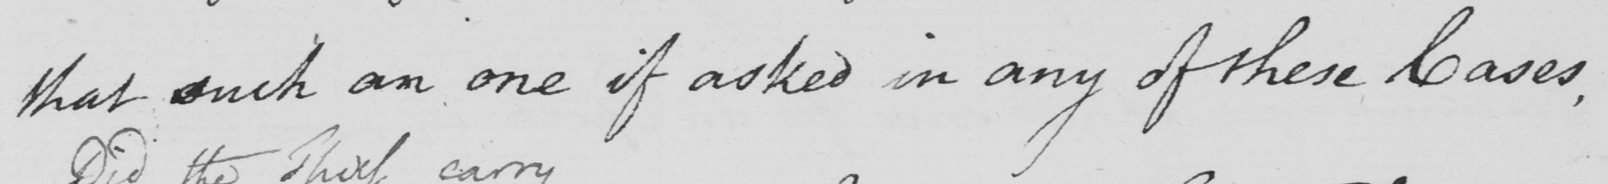Please provide the text content of this handwritten line. that such an one if asked in any of these Cases , 